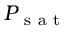<formula> <loc_0><loc_0><loc_500><loc_500>P _ { s a t }</formula> 